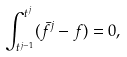Convert formula to latex. <formula><loc_0><loc_0><loc_500><loc_500>\int _ { t ^ { j - 1 } } ^ { t ^ { j } } ( \bar { f } ^ { j } - f ) = 0 ,</formula> 